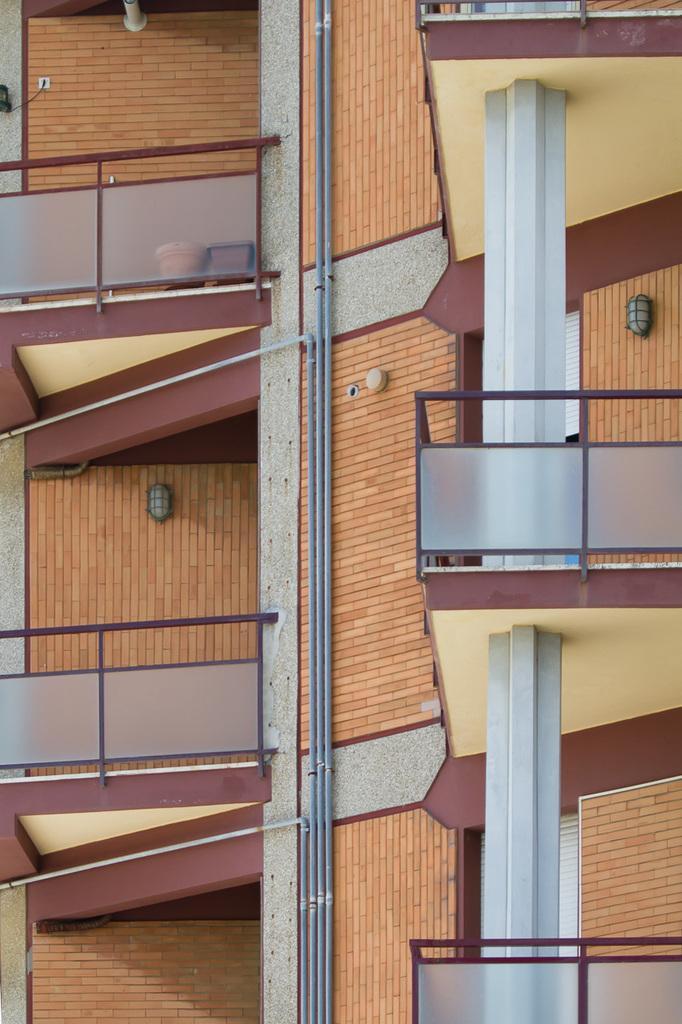Can you describe this image briefly? This is a picture of a building, where there are pipes, iron rods, pots, lights. 